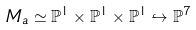Convert formula to latex. <formula><loc_0><loc_0><loc_500><loc_500>M _ { a } \simeq { \mathbb { P } } ^ { 1 } \times { \mathbb { P } } ^ { 1 } \times { \mathbb { P } } ^ { 1 } \hookrightarrow { \mathbb { P } } ^ { 7 }</formula> 